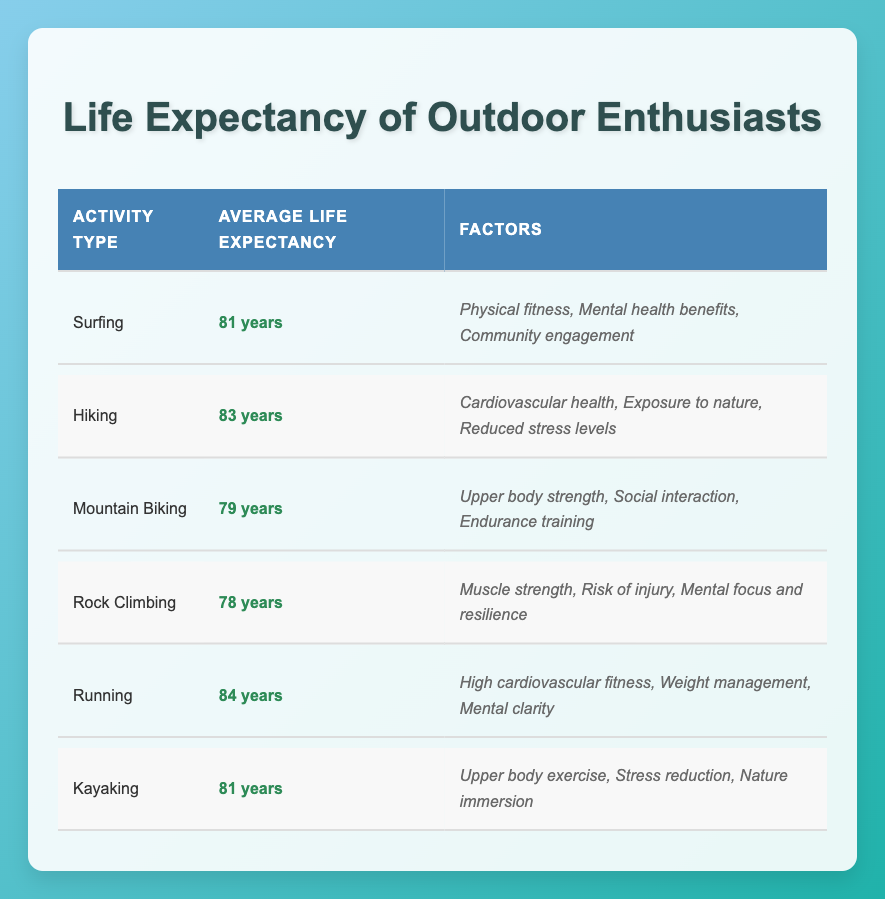What is the average life expectancy of surfers? The table shows the Life Expectancy of Outdoor Enthusiasts with their respective activities. For surfers, the Average Life Expectancy is clearly stated as 81 years.
Answer: 81 years Which outdoor activity has the highest average life expectancy? Scanning through the table, the activity with the highest Average Life Expectancy is Running, which has a reported average of 84 years.
Answer: Running Is the average life expectancy of mountain bikers higher than rock climbers? Looking at the table, Mountain Biking shows an Average Life Expectancy of 79 years, while Rock Climbing shows 78 years. Since 79 is greater than 78, mountain bikers have a higher life expectancy.
Answer: Yes What is the difference in average life expectancy between hikers and mountain bikers? Hikers have an Average Life Expectancy of 83 years, while mountain bikers have 79 years. To find the difference, we subtract 79 from 83, which equals 4 years.
Answer: 4 years Is kayaking associated with better factors for life expectancy than rock climbing? Kayaking has factors such as upper body exercise, stress reduction, and nature immersion. In contrast, rock climbing's factors are muscle strength, risk of injury, and mental focus/resilience. Without numerical comparison, we cannot determine if one is definitively better than the other; rather, they provide different benefits.
Answer: No What factors contribute to the average life expectancy of runners? The table lists three key factors that contribute to the Average Life Expectancy of runners: high cardiovascular fitness, weight management, and mental clarity. These factors collectively promote a longer life expectancy.
Answer: High cardiovascular fitness, weight management, mental clarity What is the average life expectancy of outdoor enthusiasts who engage in water-related activities (surfing and kayaking)? First, we check the average life expectancy of surfing (81 years) and kayaking (81 years). To find the average for these two, add them together (81 + 81 = 162) and then divide by 2, resulting in an average of 81 years.
Answer: 81 years Which activity has a life expectancy closest to the average of all activities listed? The average life expectancy of all six activities can be calculated as (81 + 83 + 79 + 78 + 84 + 81) = 486, divided by 6 gives an average of 81 years. Comparing each activity, Mountain Biking (79 years) has the closest life expectancy to this average.
Answer: Mountain Biking 